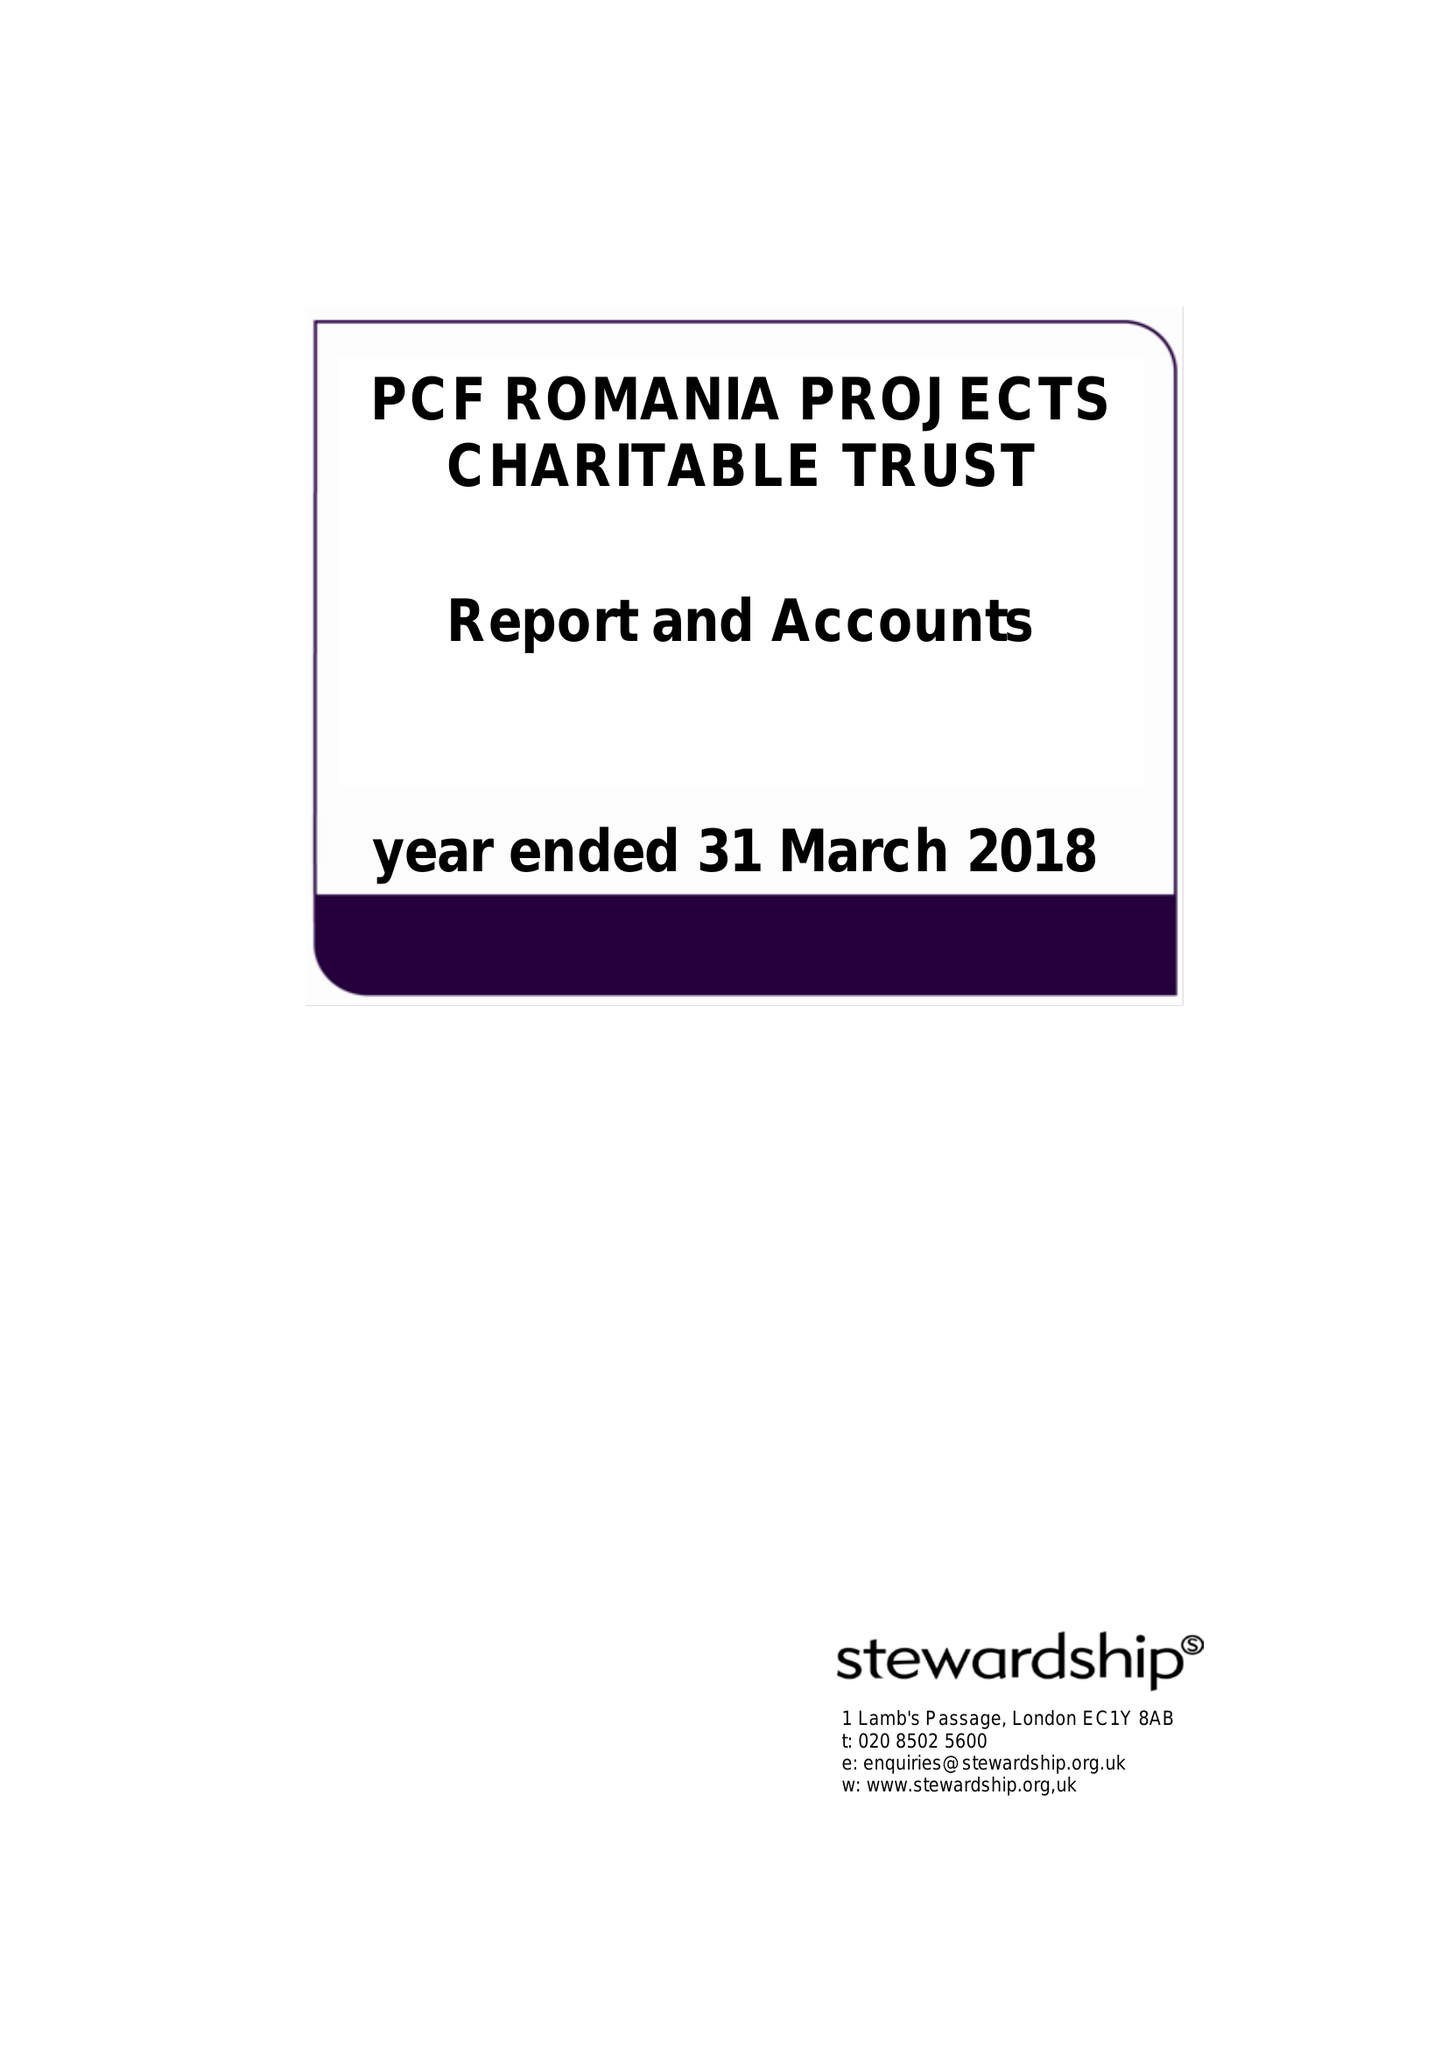What is the value for the charity_number?
Answer the question using a single word or phrase. 1114182 